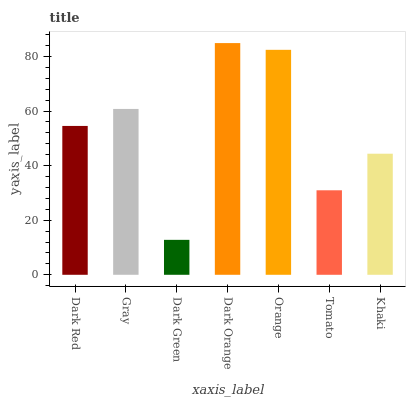Is Dark Green the minimum?
Answer yes or no. Yes. Is Dark Orange the maximum?
Answer yes or no. Yes. Is Gray the minimum?
Answer yes or no. No. Is Gray the maximum?
Answer yes or no. No. Is Gray greater than Dark Red?
Answer yes or no. Yes. Is Dark Red less than Gray?
Answer yes or no. Yes. Is Dark Red greater than Gray?
Answer yes or no. No. Is Gray less than Dark Red?
Answer yes or no. No. Is Dark Red the high median?
Answer yes or no. Yes. Is Dark Red the low median?
Answer yes or no. Yes. Is Dark Orange the high median?
Answer yes or no. No. Is Orange the low median?
Answer yes or no. No. 